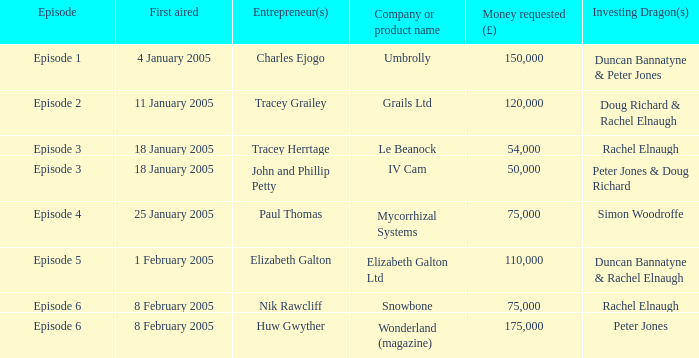What is the typical monetary request in the episode that first aired on 18 january 2005 by the company/product titled iv cam? 50000.0. 